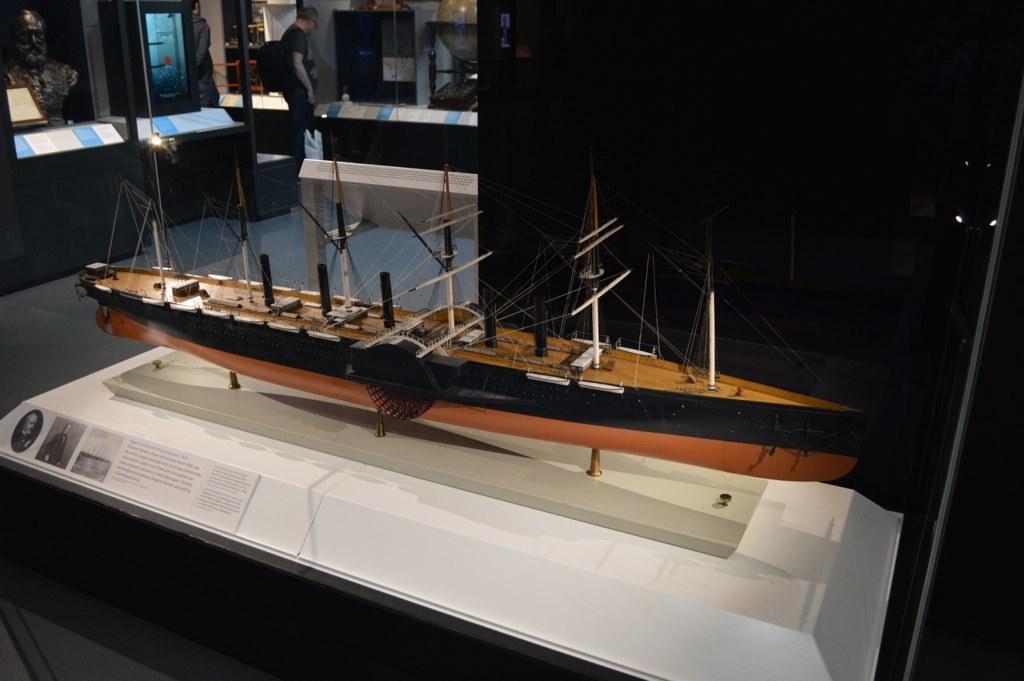How would you summarize this image in a sentence or two? In the image we can see there is a toy of a ship kept in the glass box and there is a statue of a person kept in the glass box. There are other items kept in the glass box and there is a man standing on the floor. 